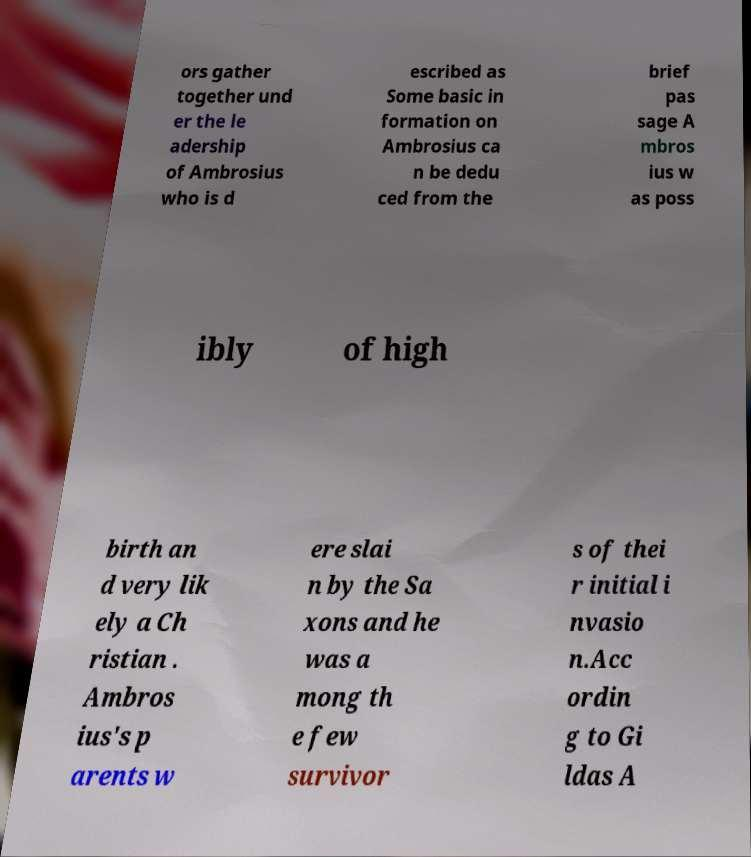For documentation purposes, I need the text within this image transcribed. Could you provide that? ors gather together und er the le adership of Ambrosius who is d escribed as Some basic in formation on Ambrosius ca n be dedu ced from the brief pas sage A mbros ius w as poss ibly of high birth an d very lik ely a Ch ristian . Ambros ius's p arents w ere slai n by the Sa xons and he was a mong th e few survivor s of thei r initial i nvasio n.Acc ordin g to Gi ldas A 